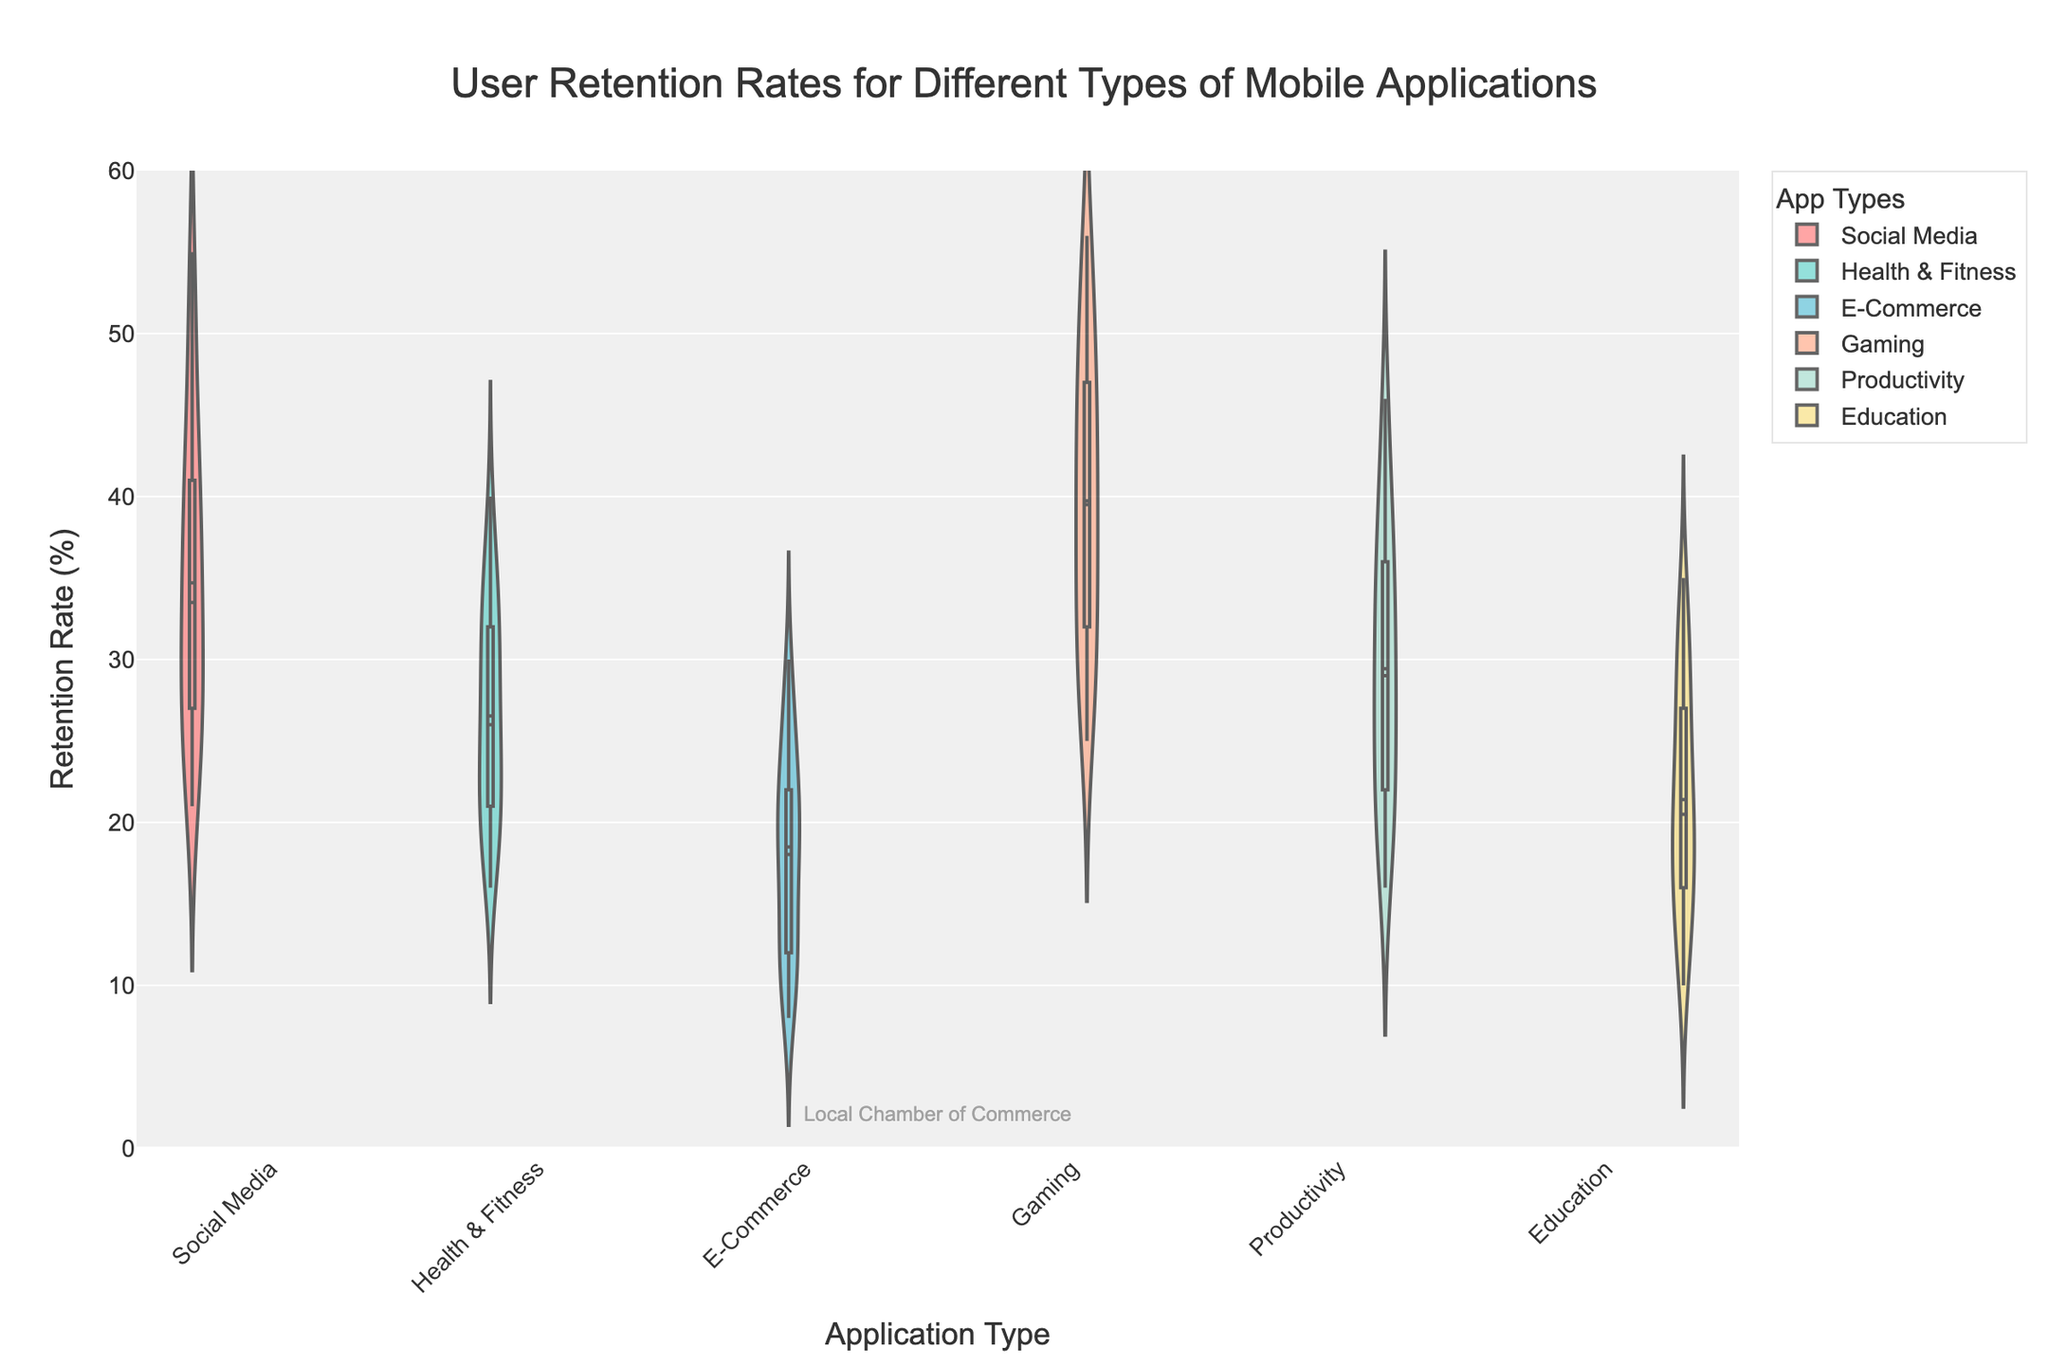Which application type has the highest median retention rate? To determine the application type with the highest median retention rate, we need to look at the median indicators (horizontal lines inside the violin plots). From the figure, it’s clear that 'Gaming' has the highest median line among all application types.
Answer: Gaming Which application type shows the most variation in retention rates? Variation in retention rates is indicated by the width and spread of the violin plot. The 'Gaming' applications display the widest distribution, indicating the most variation in retention rates.
Answer: Gaming What is the approximate median retention rate for Productivity apps in the first month? We need to examine the median line inside the 'Productivity' violin plot. For the first month, the median retention rate for Productivity apps appears to be around 42%.
Answer: 42% Between Social Media and E-Commerce apps, which one has higher average retention rates across six months? Averaging the retention rates across six months for both Social Media and E-Commerce apps, we observe that Social Media tends to have higher values consistently compared to E-Commerce.
Answer: Social Media What can be inferred about the retention rates of Education apps over six months? Observing the 'Education' violin plots across the months, we see a consistent decrease in retention rates, indicating that user retention decreases steadily over time for Education apps.
Answer: Decreasing trend Which month shows the lowest retention rates for Health & Fitness apps? By looking at the lowest points of the 'Health & Fitness' violin plots over the months, we identify that the sixth month has the lowest retention rates.
Answer: Sixth month How much higher is the median retention rate of Social Media apps compared to E-Commerce apps in the first month? To find the difference, we observe the median lines for both Social Media (around 50%) and E-Commerce (around 27%). The difference is roughly 50% - 27% = 23%.
Answer: 23% Do all application types exhibit a decrease in retention rates over the six months? By examining each type's series of violin plots, we notice that the retention rates generally decrease over time for all application types.
Answer: Yes Which app type maintains the highest retention rate at the end of the six-month period? At the end of the six-month period, we need to look at the rightmost violin plots. 'Gaming' apps maintain the highest retention rate compared to other types.
Answer: Gaming Is there any application type that shows a slight retention improvement in any month? No application type exhibits an increase in retention rates across successive months as visualized by the violin plots. All plots depict a decline over time.
Answer: No 